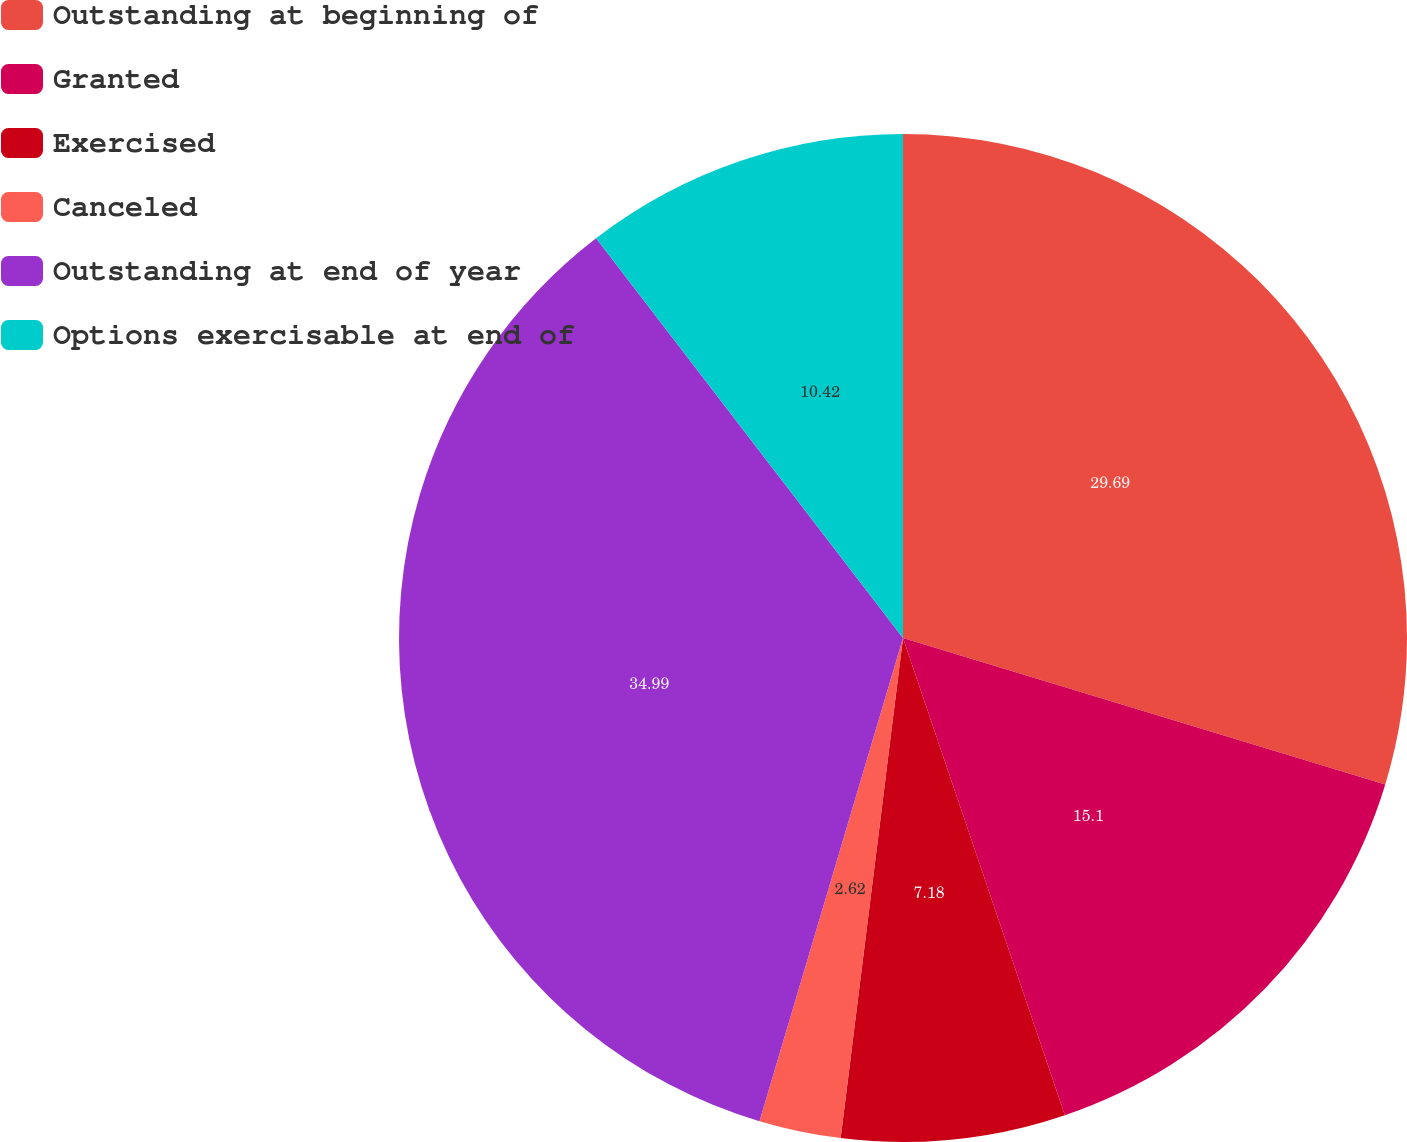Convert chart to OTSL. <chart><loc_0><loc_0><loc_500><loc_500><pie_chart><fcel>Outstanding at beginning of<fcel>Granted<fcel>Exercised<fcel>Canceled<fcel>Outstanding at end of year<fcel>Options exercisable at end of<nl><fcel>29.69%<fcel>15.1%<fcel>7.18%<fcel>2.62%<fcel>34.98%<fcel>10.42%<nl></chart> 